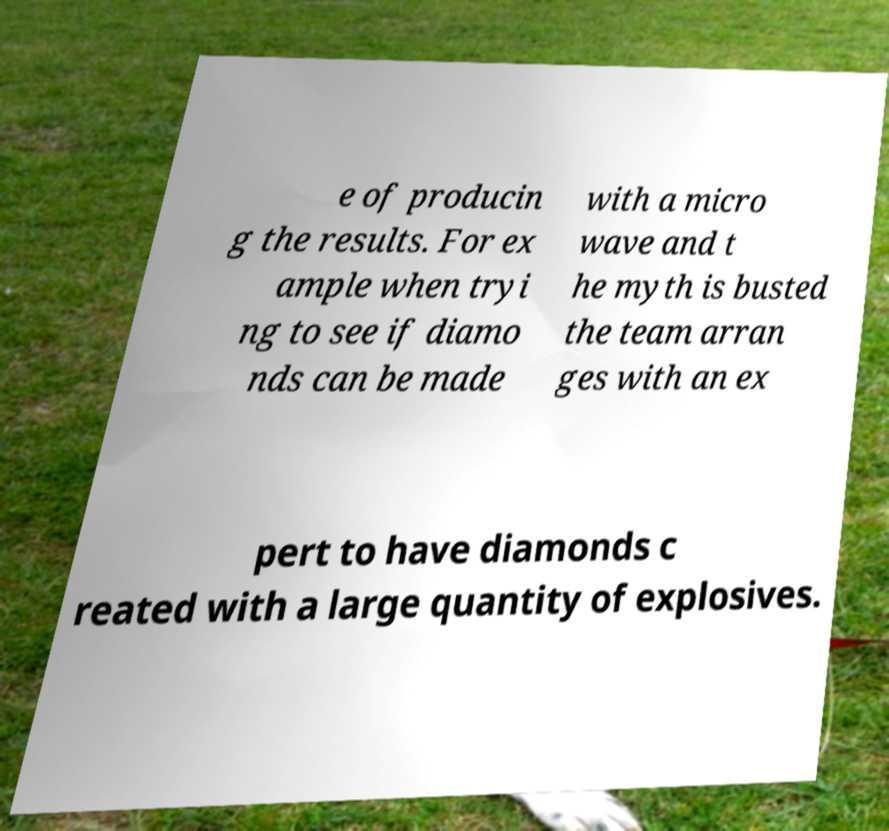I need the written content from this picture converted into text. Can you do that? e of producin g the results. For ex ample when tryi ng to see if diamo nds can be made with a micro wave and t he myth is busted the team arran ges with an ex pert to have diamonds c reated with a large quantity of explosives. 